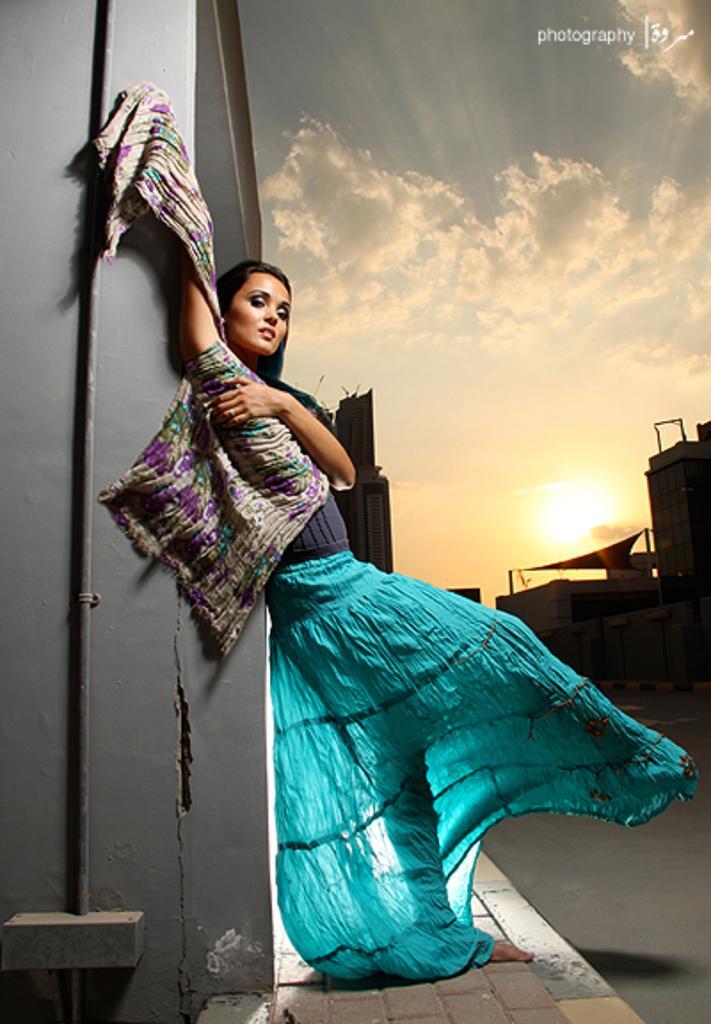In one or two sentences, can you explain what this image depicts? In the image we can see a woman standing wearing clothes. Here we can see footpath, buildings, cloudy sky and the sun. On the top right, we can see watermark. 